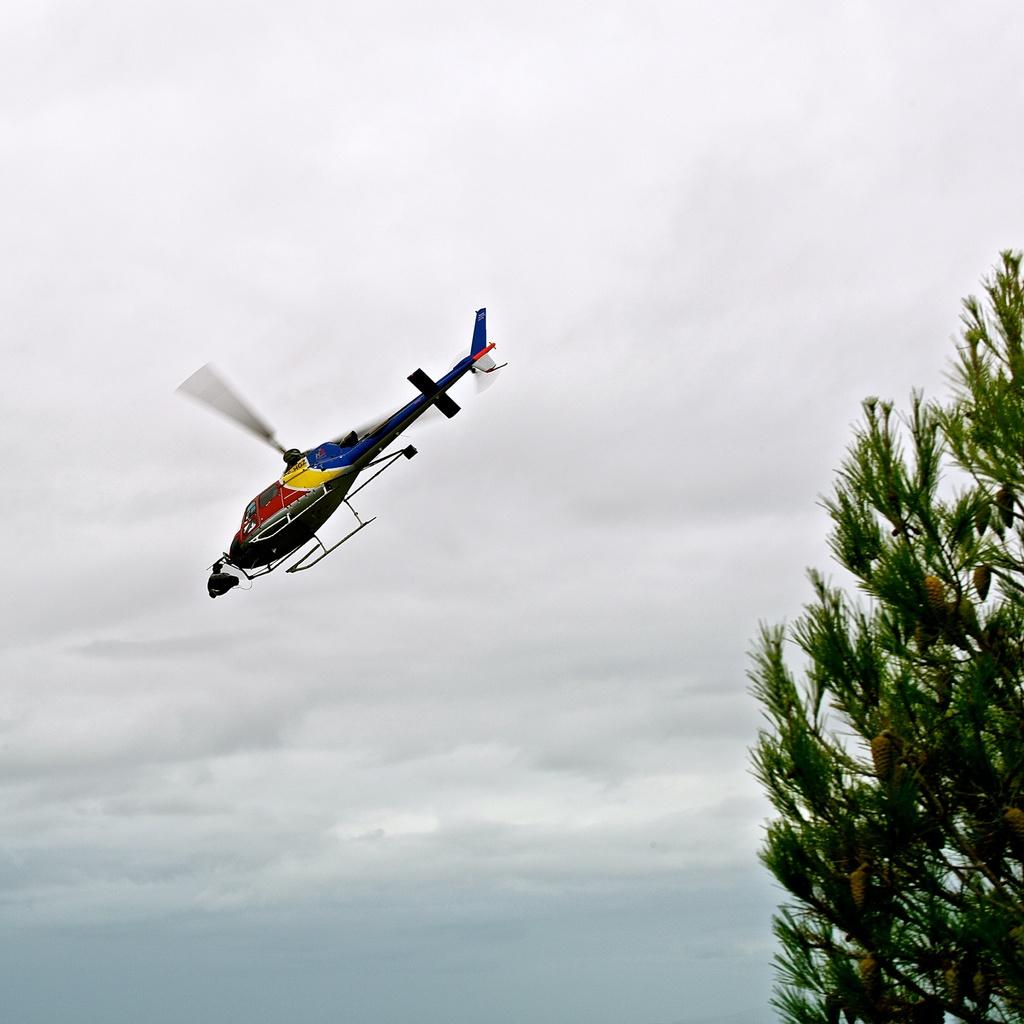What type of vegetation can be seen on the right side of the image? There are leaves on the right side of the image. What is flying in the sky in the center of the image? There is a helicopter flying in the sky in the center of the image. How would you describe the sky in the image? The sky is cloudy in the image. What color is the sock hanging on the helicopter in the image? There is no sock present in the image; it features leaves, a helicopter, and a cloudy sky. How does the water affect the temperature in the image? There is no water present in the image, so it cannot affect the temperature. 